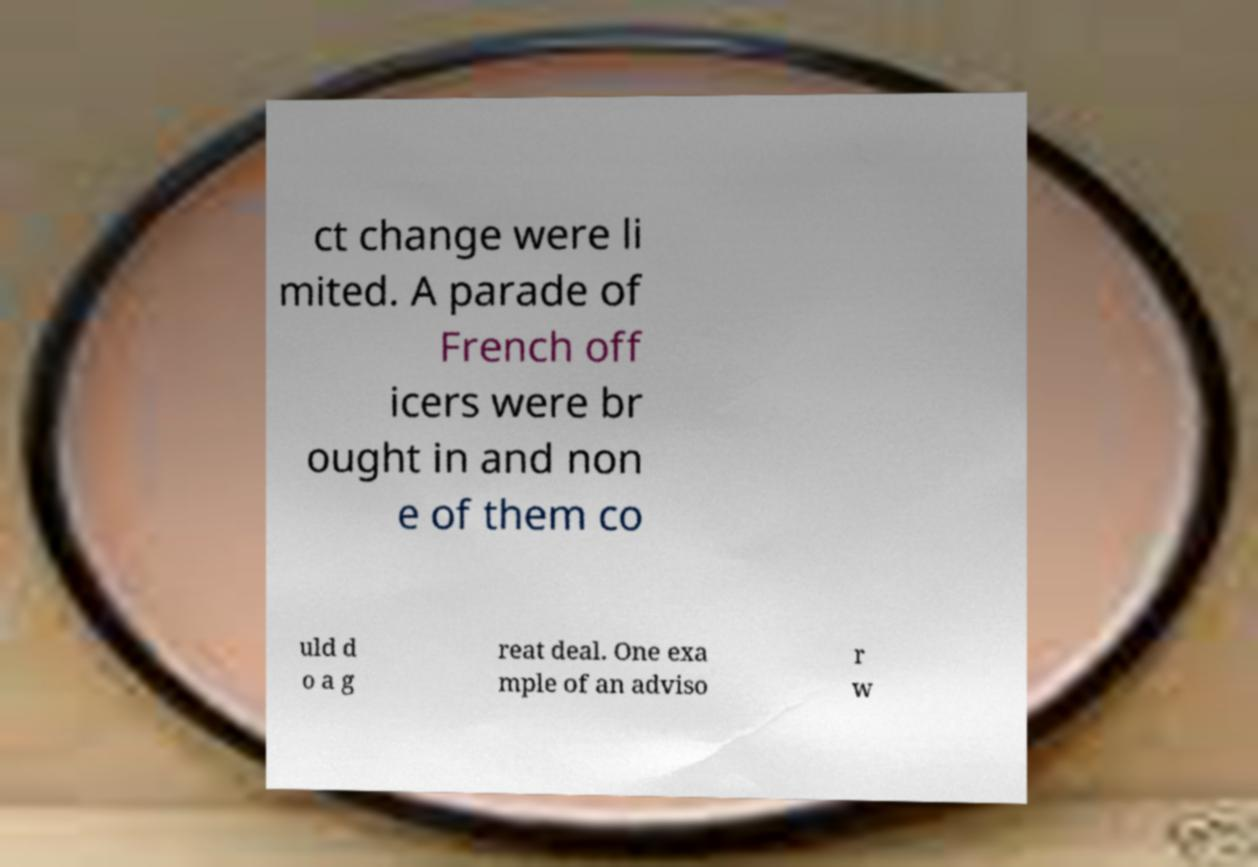Could you extract and type out the text from this image? ct change were li mited. A parade of French off icers were br ought in and non e of them co uld d o a g reat deal. One exa mple of an adviso r w 